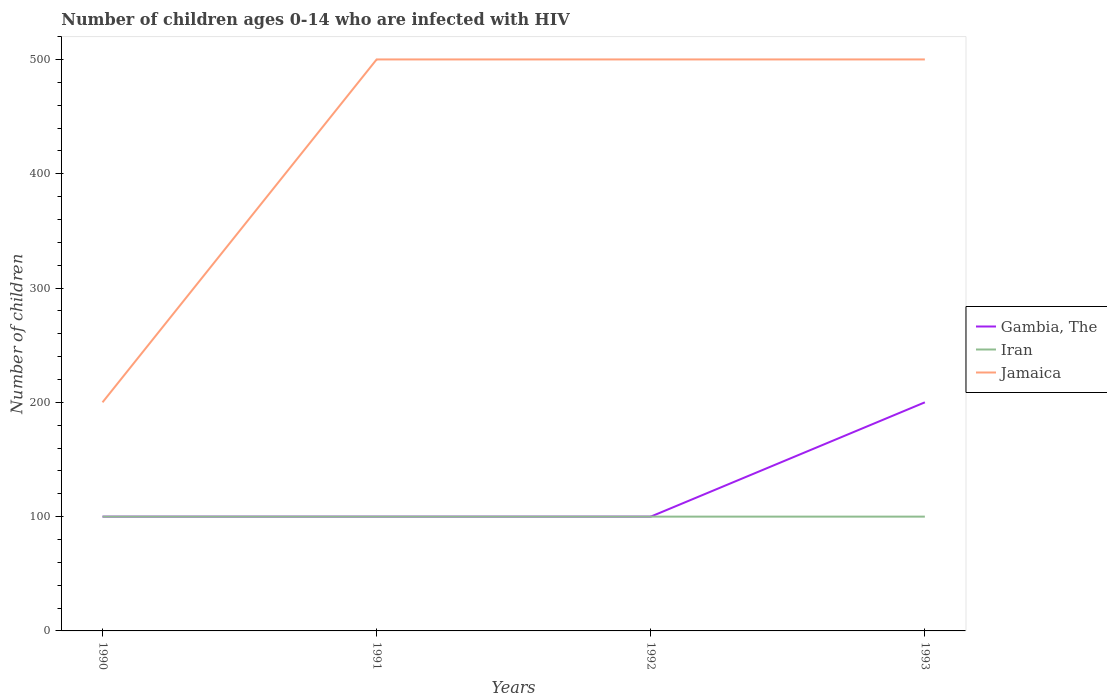How many different coloured lines are there?
Make the answer very short. 3. Across all years, what is the maximum number of HIV infected children in Gambia, The?
Provide a succinct answer. 100. In which year was the number of HIV infected children in Jamaica maximum?
Your answer should be very brief. 1990. What is the total number of HIV infected children in Jamaica in the graph?
Offer a very short reply. 0. What is the difference between the highest and the second highest number of HIV infected children in Iran?
Keep it short and to the point. 0. What is the difference between the highest and the lowest number of HIV infected children in Iran?
Provide a short and direct response. 0. Is the number of HIV infected children in Jamaica strictly greater than the number of HIV infected children in Gambia, The over the years?
Your answer should be compact. No. How many lines are there?
Make the answer very short. 3. How many years are there in the graph?
Your answer should be compact. 4. What is the difference between two consecutive major ticks on the Y-axis?
Offer a very short reply. 100. Are the values on the major ticks of Y-axis written in scientific E-notation?
Make the answer very short. No. Does the graph contain grids?
Your answer should be very brief. No. Where does the legend appear in the graph?
Provide a short and direct response. Center right. How many legend labels are there?
Your answer should be compact. 3. How are the legend labels stacked?
Ensure brevity in your answer.  Vertical. What is the title of the graph?
Your answer should be compact. Number of children ages 0-14 who are infected with HIV. Does "Haiti" appear as one of the legend labels in the graph?
Your answer should be very brief. No. What is the label or title of the Y-axis?
Keep it short and to the point. Number of children. What is the Number of children of Gambia, The in 1992?
Offer a terse response. 100. What is the Number of children in Iran in 1993?
Your response must be concise. 100. Across all years, what is the maximum Number of children of Iran?
Keep it short and to the point. 100. Across all years, what is the maximum Number of children of Jamaica?
Make the answer very short. 500. What is the total Number of children in Jamaica in the graph?
Keep it short and to the point. 1700. What is the difference between the Number of children of Iran in 1990 and that in 1991?
Keep it short and to the point. 0. What is the difference between the Number of children in Jamaica in 1990 and that in 1991?
Make the answer very short. -300. What is the difference between the Number of children of Iran in 1990 and that in 1992?
Ensure brevity in your answer.  0. What is the difference between the Number of children in Jamaica in 1990 and that in 1992?
Your answer should be compact. -300. What is the difference between the Number of children in Gambia, The in 1990 and that in 1993?
Give a very brief answer. -100. What is the difference between the Number of children of Iran in 1990 and that in 1993?
Ensure brevity in your answer.  0. What is the difference between the Number of children of Jamaica in 1990 and that in 1993?
Provide a short and direct response. -300. What is the difference between the Number of children in Gambia, The in 1991 and that in 1993?
Ensure brevity in your answer.  -100. What is the difference between the Number of children in Gambia, The in 1992 and that in 1993?
Your answer should be compact. -100. What is the difference between the Number of children in Jamaica in 1992 and that in 1993?
Your response must be concise. 0. What is the difference between the Number of children of Gambia, The in 1990 and the Number of children of Jamaica in 1991?
Give a very brief answer. -400. What is the difference between the Number of children in Iran in 1990 and the Number of children in Jamaica in 1991?
Make the answer very short. -400. What is the difference between the Number of children of Gambia, The in 1990 and the Number of children of Iran in 1992?
Keep it short and to the point. 0. What is the difference between the Number of children of Gambia, The in 1990 and the Number of children of Jamaica in 1992?
Provide a short and direct response. -400. What is the difference between the Number of children of Iran in 1990 and the Number of children of Jamaica in 1992?
Provide a succinct answer. -400. What is the difference between the Number of children of Gambia, The in 1990 and the Number of children of Jamaica in 1993?
Keep it short and to the point. -400. What is the difference between the Number of children of Iran in 1990 and the Number of children of Jamaica in 1993?
Your response must be concise. -400. What is the difference between the Number of children in Gambia, The in 1991 and the Number of children in Jamaica in 1992?
Provide a short and direct response. -400. What is the difference between the Number of children in Iran in 1991 and the Number of children in Jamaica in 1992?
Your answer should be very brief. -400. What is the difference between the Number of children of Gambia, The in 1991 and the Number of children of Jamaica in 1993?
Provide a short and direct response. -400. What is the difference between the Number of children of Iran in 1991 and the Number of children of Jamaica in 1993?
Offer a terse response. -400. What is the difference between the Number of children of Gambia, The in 1992 and the Number of children of Jamaica in 1993?
Make the answer very short. -400. What is the difference between the Number of children in Iran in 1992 and the Number of children in Jamaica in 1993?
Ensure brevity in your answer.  -400. What is the average Number of children of Gambia, The per year?
Give a very brief answer. 125. What is the average Number of children of Jamaica per year?
Keep it short and to the point. 425. In the year 1990, what is the difference between the Number of children of Gambia, The and Number of children of Jamaica?
Ensure brevity in your answer.  -100. In the year 1990, what is the difference between the Number of children in Iran and Number of children in Jamaica?
Provide a short and direct response. -100. In the year 1991, what is the difference between the Number of children in Gambia, The and Number of children in Jamaica?
Provide a succinct answer. -400. In the year 1991, what is the difference between the Number of children in Iran and Number of children in Jamaica?
Ensure brevity in your answer.  -400. In the year 1992, what is the difference between the Number of children of Gambia, The and Number of children of Iran?
Offer a very short reply. 0. In the year 1992, what is the difference between the Number of children of Gambia, The and Number of children of Jamaica?
Provide a short and direct response. -400. In the year 1992, what is the difference between the Number of children of Iran and Number of children of Jamaica?
Give a very brief answer. -400. In the year 1993, what is the difference between the Number of children in Gambia, The and Number of children in Iran?
Make the answer very short. 100. In the year 1993, what is the difference between the Number of children of Gambia, The and Number of children of Jamaica?
Your response must be concise. -300. In the year 1993, what is the difference between the Number of children in Iran and Number of children in Jamaica?
Offer a terse response. -400. What is the ratio of the Number of children of Gambia, The in 1990 to that in 1991?
Your answer should be compact. 1. What is the ratio of the Number of children in Gambia, The in 1990 to that in 1992?
Your answer should be very brief. 1. What is the ratio of the Number of children of Gambia, The in 1990 to that in 1993?
Your answer should be compact. 0.5. What is the ratio of the Number of children in Jamaica in 1990 to that in 1993?
Ensure brevity in your answer.  0.4. What is the ratio of the Number of children in Gambia, The in 1991 to that in 1992?
Provide a short and direct response. 1. What is the ratio of the Number of children of Iran in 1992 to that in 1993?
Your answer should be compact. 1. What is the ratio of the Number of children in Jamaica in 1992 to that in 1993?
Offer a terse response. 1. What is the difference between the highest and the second highest Number of children of Gambia, The?
Your answer should be very brief. 100. What is the difference between the highest and the second highest Number of children in Iran?
Make the answer very short. 0. What is the difference between the highest and the lowest Number of children in Jamaica?
Your answer should be compact. 300. 